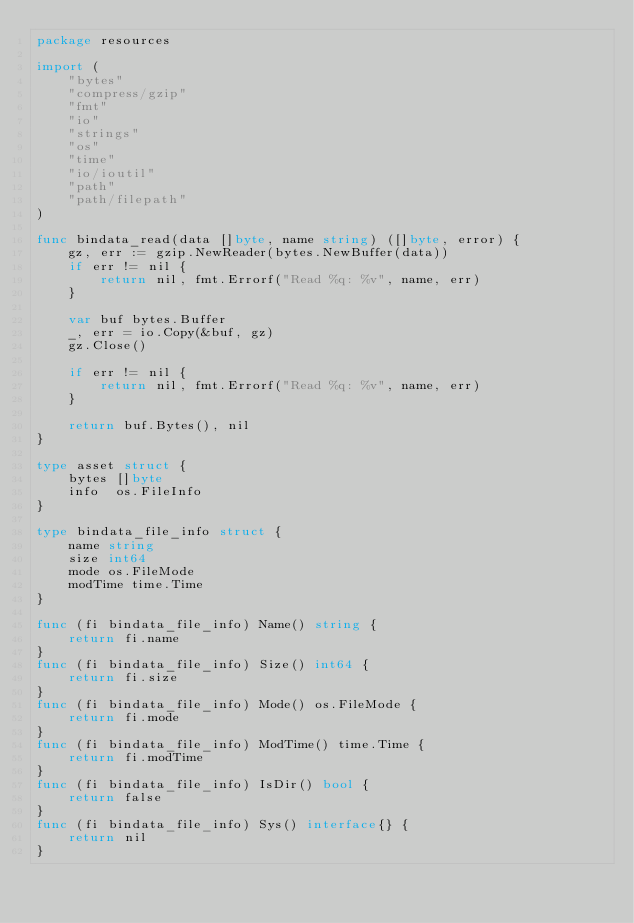<code> <loc_0><loc_0><loc_500><loc_500><_Go_>package resources

import (
	"bytes"
	"compress/gzip"
	"fmt"
	"io"
	"strings"
	"os"
	"time"
	"io/ioutil"
	"path"
	"path/filepath"
)

func bindata_read(data []byte, name string) ([]byte, error) {
	gz, err := gzip.NewReader(bytes.NewBuffer(data))
	if err != nil {
		return nil, fmt.Errorf("Read %q: %v", name, err)
	}

	var buf bytes.Buffer
	_, err = io.Copy(&buf, gz)
	gz.Close()

	if err != nil {
		return nil, fmt.Errorf("Read %q: %v", name, err)
	}

	return buf.Bytes(), nil
}

type asset struct {
	bytes []byte
	info  os.FileInfo
}

type bindata_file_info struct {
	name string
	size int64
	mode os.FileMode
	modTime time.Time
}

func (fi bindata_file_info) Name() string {
	return fi.name
}
func (fi bindata_file_info) Size() int64 {
	return fi.size
}
func (fi bindata_file_info) Mode() os.FileMode {
	return fi.mode
}
func (fi bindata_file_info) ModTime() time.Time {
	return fi.modTime
}
func (fi bindata_file_info) IsDir() bool {
	return false
}
func (fi bindata_file_info) Sys() interface{} {
	return nil
}
</code> 